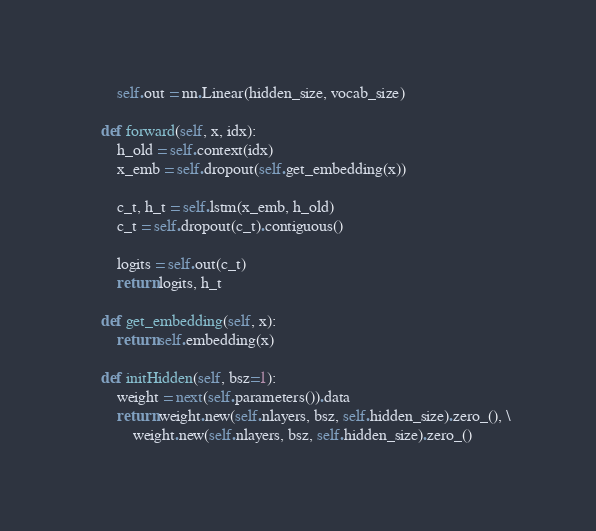Convert code to text. <code><loc_0><loc_0><loc_500><loc_500><_Python_>        self.out = nn.Linear(hidden_size, vocab_size)

    def forward(self, x, idx):
        h_old = self.context(idx)
        x_emb = self.dropout(self.get_embedding(x))

        c_t, h_t = self.lstm(x_emb, h_old)
        c_t = self.dropout(c_t).contiguous()

        logits = self.out(c_t)
        return logits, h_t

    def get_embedding(self, x):
        return self.embedding(x)

    def initHidden(self, bsz=1):
        weight = next(self.parameters()).data
        return weight.new(self.nlayers, bsz, self.hidden_size).zero_(), \
            weight.new(self.nlayers, bsz, self.hidden_size).zero_()
</code> 